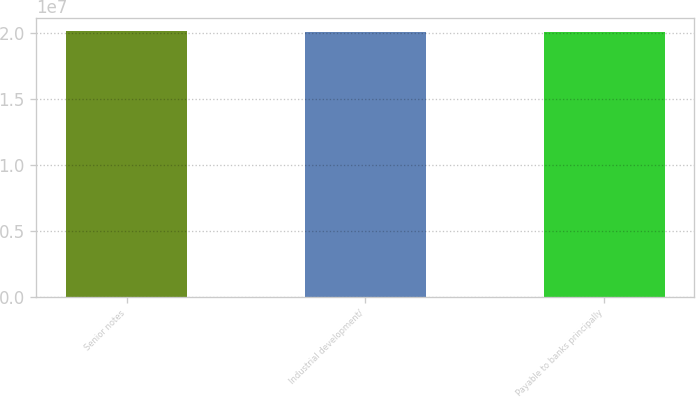Convert chart to OTSL. <chart><loc_0><loc_0><loc_500><loc_500><bar_chart><fcel>Senior notes<fcel>Industrial development/<fcel>Payable to banks principally<nl><fcel>2.0132e+07<fcel>2.0112e+07<fcel>2.0102e+07<nl></chart> 